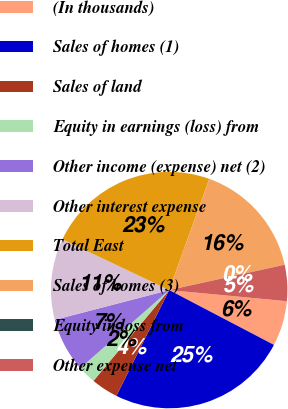<chart> <loc_0><loc_0><loc_500><loc_500><pie_chart><fcel>(In thousands)<fcel>Sales of homes (1)<fcel>Sales of land<fcel>Equity in earnings (loss) from<fcel>Other income (expense) net (2)<fcel>Other interest expense<fcel>Total East<fcel>Sales of homes (3)<fcel>Equity in loss from<fcel>Other expense net<nl><fcel>6.17%<fcel>24.69%<fcel>3.7%<fcel>2.47%<fcel>7.41%<fcel>11.11%<fcel>23.45%<fcel>16.05%<fcel>0.0%<fcel>4.94%<nl></chart> 